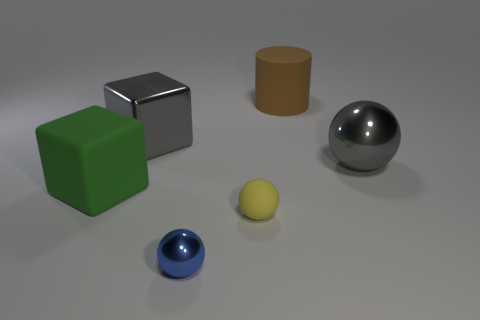Add 2 tiny yellow rubber objects. How many objects exist? 8 Subtract all cubes. How many objects are left? 4 Add 4 small yellow spheres. How many small yellow spheres are left? 5 Add 6 tiny blue matte spheres. How many tiny blue matte spheres exist? 6 Subtract 0 purple cylinders. How many objects are left? 6 Subtract all small blue objects. Subtract all matte cylinders. How many objects are left? 4 